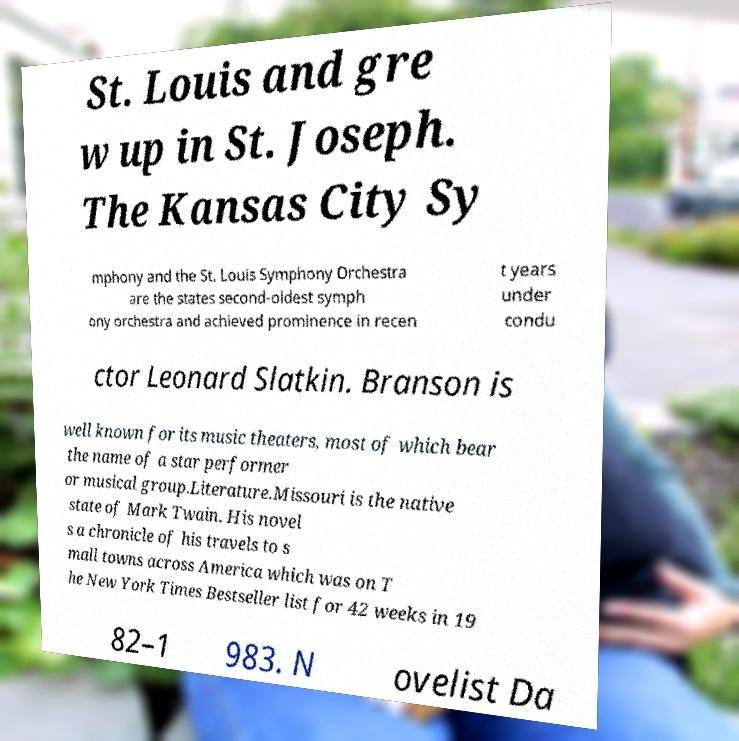There's text embedded in this image that I need extracted. Can you transcribe it verbatim? St. Louis and gre w up in St. Joseph. The Kansas City Sy mphony and the St. Louis Symphony Orchestra are the states second-oldest symph ony orchestra and achieved prominence in recen t years under condu ctor Leonard Slatkin. Branson is well known for its music theaters, most of which bear the name of a star performer or musical group.Literature.Missouri is the native state of Mark Twain. His novel s a chronicle of his travels to s mall towns across America which was on T he New York Times Bestseller list for 42 weeks in 19 82–1 983. N ovelist Da 